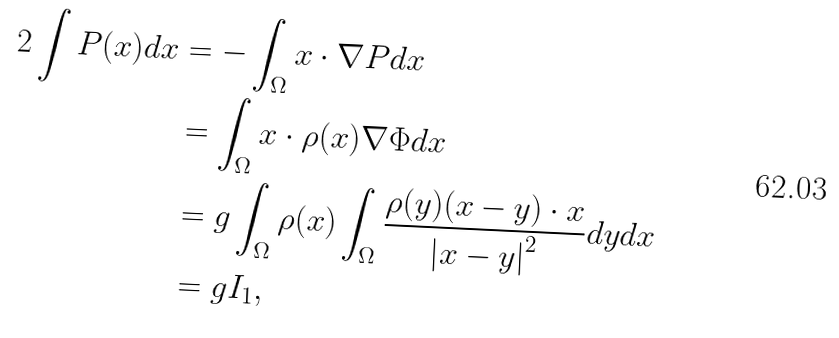<formula> <loc_0><loc_0><loc_500><loc_500>2 \int P ( x ) d x & = - \int _ { \Omega } x \cdot \nabla P d x \\ & = \int _ { \Omega } x \cdot \rho ( x ) \nabla \Phi d x \\ & = g \int _ { \Omega } \rho ( x ) \int _ { \Omega } \frac { \rho ( y ) ( x - y ) \cdot x } { \left | x - y \right | ^ { 2 } } d y d x \\ & = g I _ { 1 } ,</formula> 